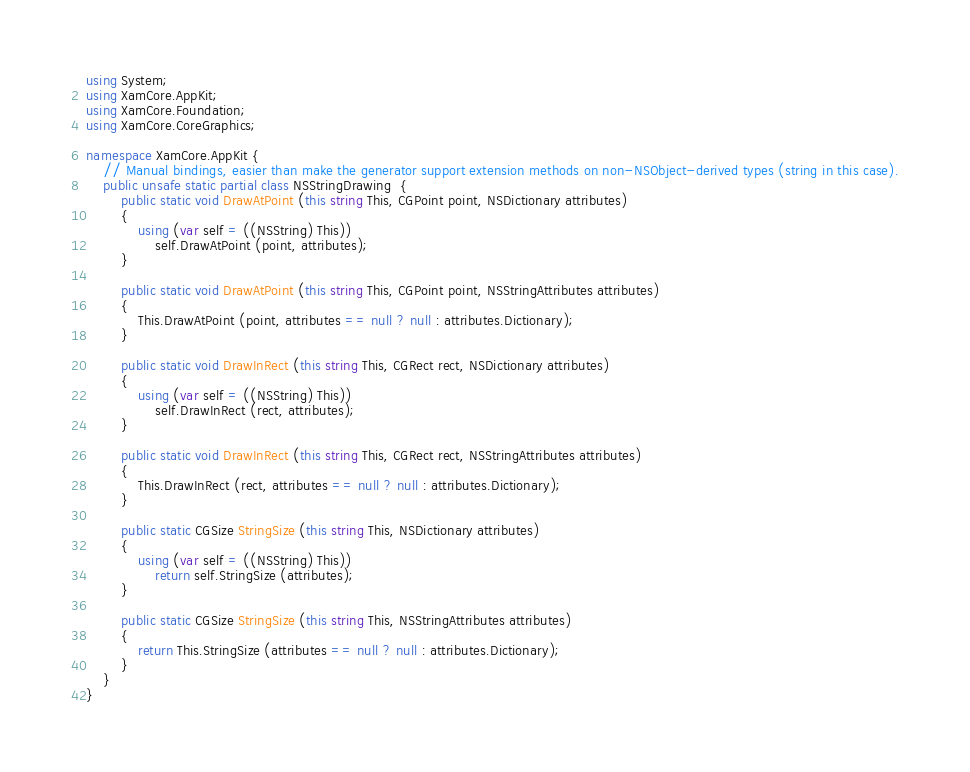Convert code to text. <code><loc_0><loc_0><loc_500><loc_500><_C#_>using System;
using XamCore.AppKit;
using XamCore.Foundation;
using XamCore.CoreGraphics;

namespace XamCore.AppKit {
	// Manual bindings, easier than make the generator support extension methods on non-NSObject-derived types (string in this case).
	public unsafe static partial class NSStringDrawing  {
		public static void DrawAtPoint (this string This, CGPoint point, NSDictionary attributes)
		{
			using (var self = ((NSString) This))
				self.DrawAtPoint (point, attributes);
		}

		public static void DrawAtPoint (this string This, CGPoint point, NSStringAttributes attributes)
		{
			This.DrawAtPoint (point, attributes == null ? null : attributes.Dictionary);
		}

		public static void DrawInRect (this string This, CGRect rect, NSDictionary attributes)
		{
			using (var self = ((NSString) This))
				self.DrawInRect (rect, attributes);
		}

		public static void DrawInRect (this string This, CGRect rect, NSStringAttributes attributes)
		{
			This.DrawInRect (rect, attributes == null ? null : attributes.Dictionary);
		}

		public static CGSize StringSize (this string This, NSDictionary attributes)
		{
			using (var self = ((NSString) This))
				return self.StringSize (attributes);
		}

		public static CGSize StringSize (this string This, NSStringAttributes attributes)
		{
			return This.StringSize (attributes == null ? null : attributes.Dictionary);
		}
	}
}
</code> 